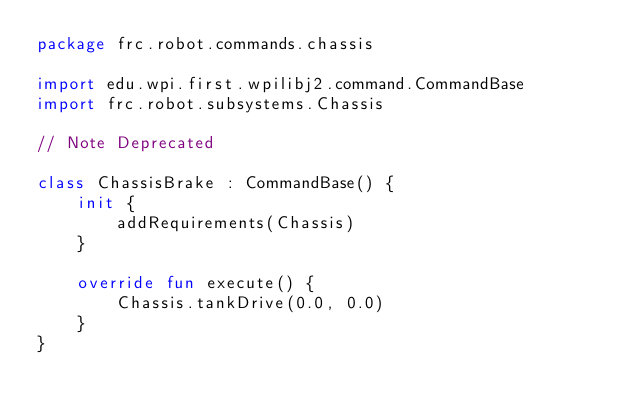<code> <loc_0><loc_0><loc_500><loc_500><_Kotlin_>package frc.robot.commands.chassis

import edu.wpi.first.wpilibj2.command.CommandBase
import frc.robot.subsystems.Chassis

// Note Deprecated

class ChassisBrake : CommandBase() {
    init {
        addRequirements(Chassis)
    }

    override fun execute() {
        Chassis.tankDrive(0.0, 0.0)
    }
}
</code> 